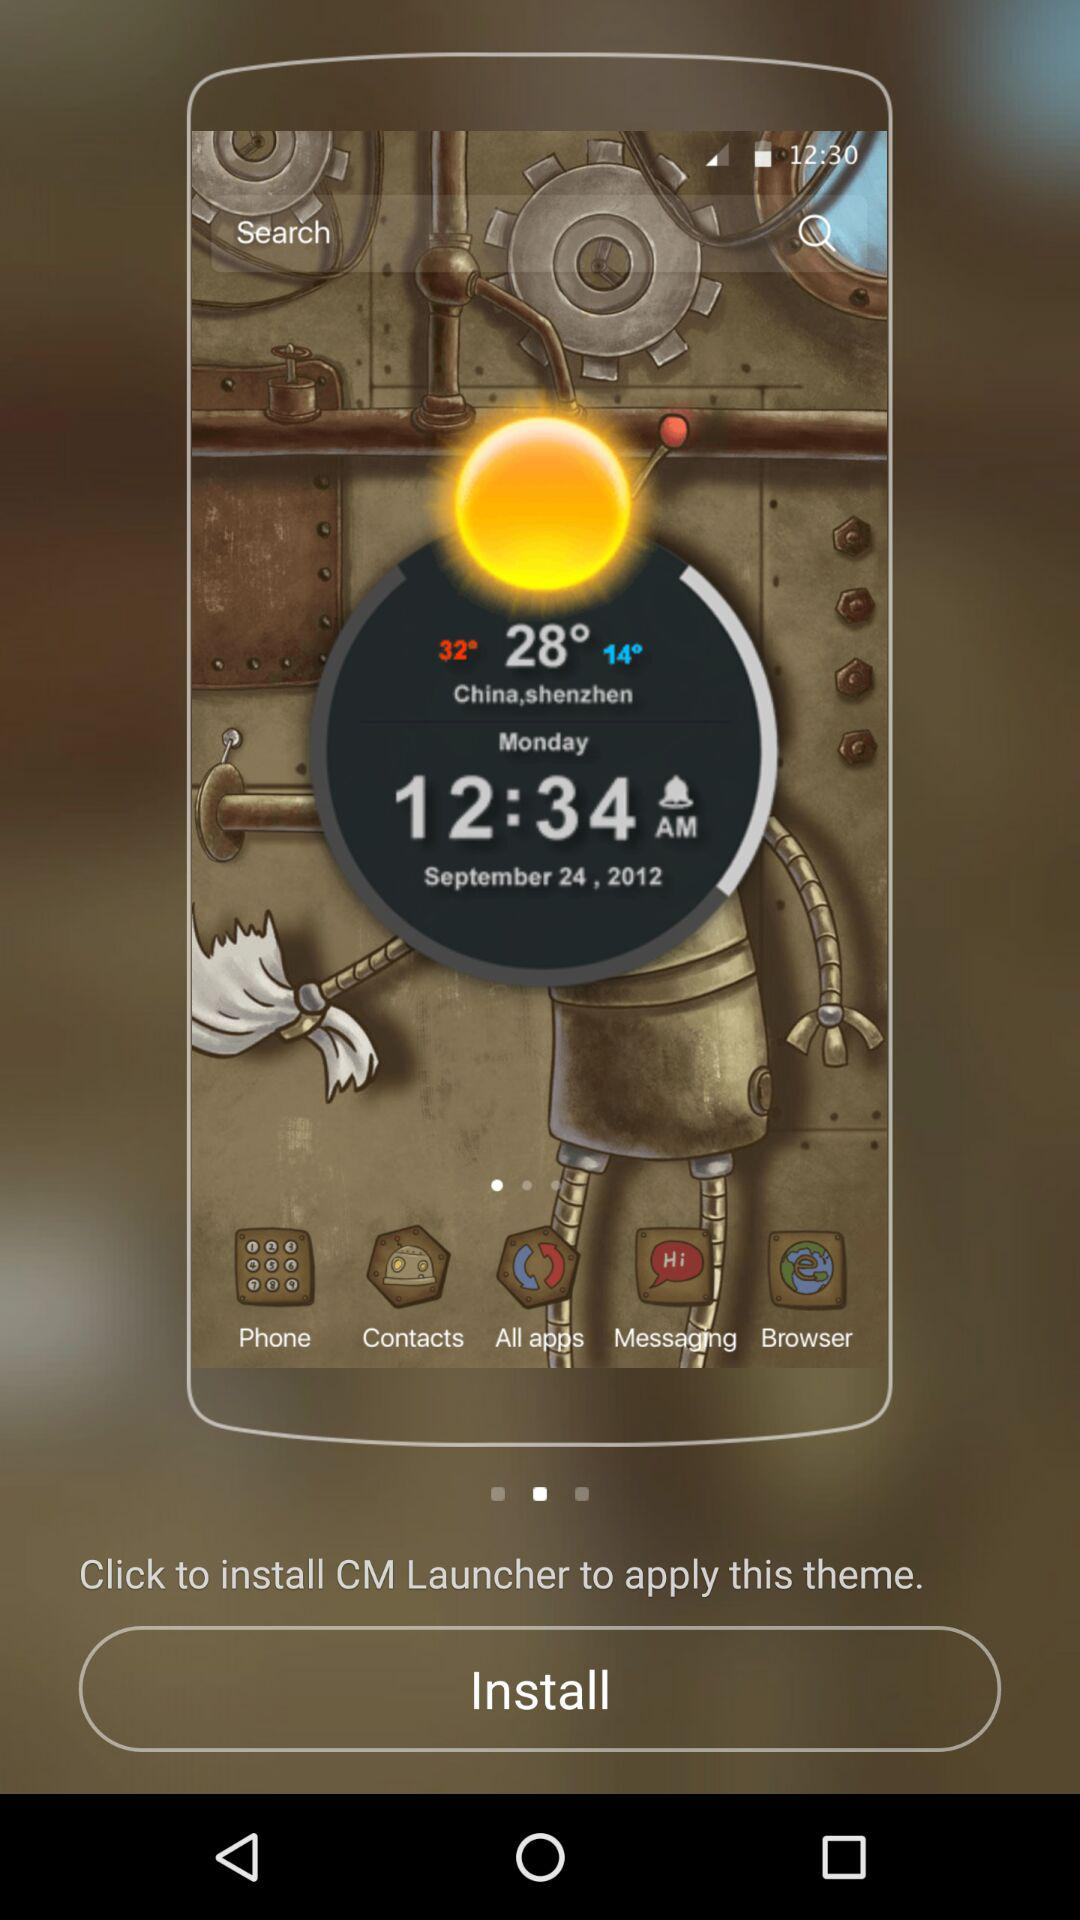What is the application name? The application name is "CM Launcher". 